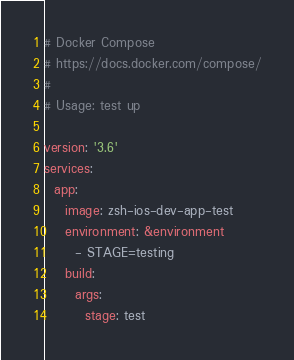Convert code to text. <code><loc_0><loc_0><loc_500><loc_500><_YAML_># Docker Compose
# https://docs.docker.com/compose/
#
# Usage: test up

version: '3.6'
services:
  app:
    image: zsh-ios-dev-app-test
    environment: &environment
      - STAGE=testing
    build:
      args:
        stage: test
</code> 